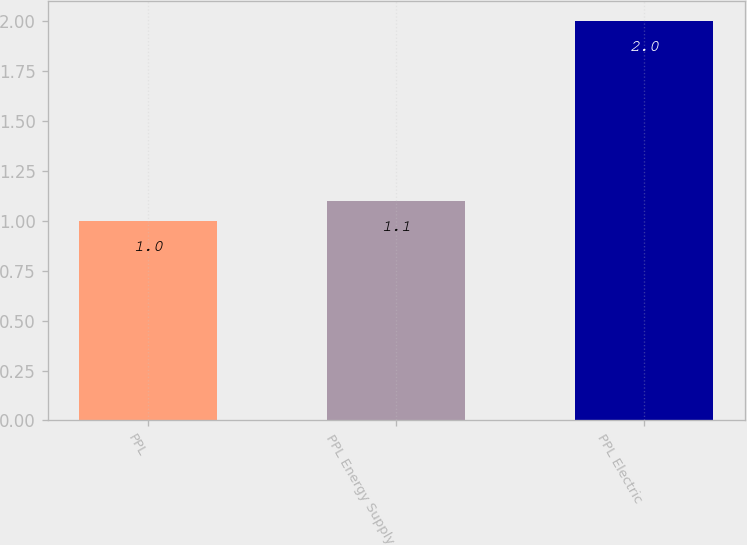Convert chart. <chart><loc_0><loc_0><loc_500><loc_500><bar_chart><fcel>PPL<fcel>PPL Energy Supply<fcel>PPL Electric<nl><fcel>1<fcel>1.1<fcel>2<nl></chart> 